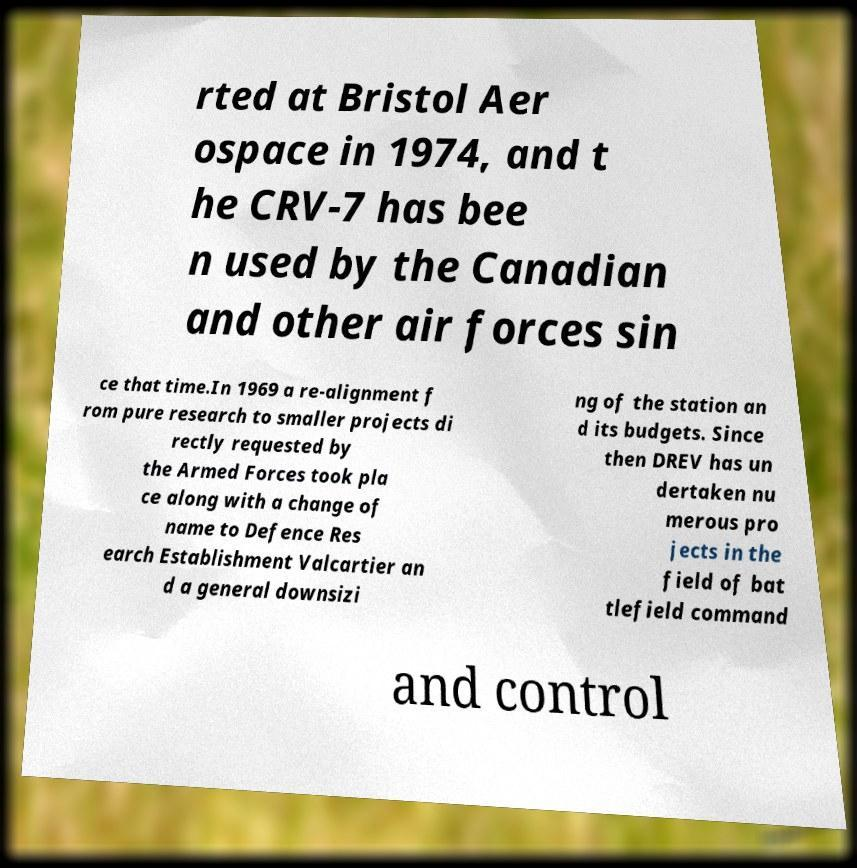Could you extract and type out the text from this image? rted at Bristol Aer ospace in 1974, and t he CRV-7 has bee n used by the Canadian and other air forces sin ce that time.In 1969 a re-alignment f rom pure research to smaller projects di rectly requested by the Armed Forces took pla ce along with a change of name to Defence Res earch Establishment Valcartier an d a general downsizi ng of the station an d its budgets. Since then DREV has un dertaken nu merous pro jects in the field of bat tlefield command and control 